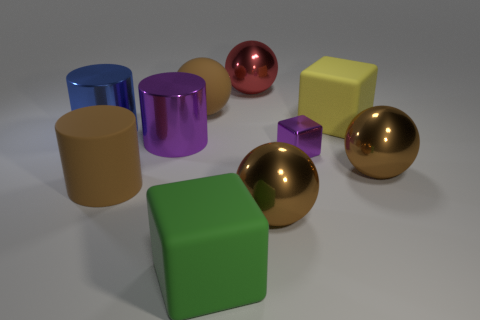How many brown spheres must be subtracted to get 1 brown spheres? 2 Subtract all green blocks. How many brown spheres are left? 3 Subtract all cyan blocks. Subtract all cyan cylinders. How many blocks are left? 3 Subtract all spheres. How many objects are left? 6 Add 3 large cylinders. How many large cylinders exist? 6 Subtract 0 green spheres. How many objects are left? 10 Subtract all green rubber cylinders. Subtract all purple cylinders. How many objects are left? 9 Add 2 matte cylinders. How many matte cylinders are left? 3 